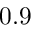<formula> <loc_0><loc_0><loc_500><loc_500>0 . 9</formula> 